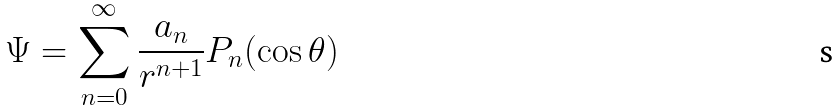Convert formula to latex. <formula><loc_0><loc_0><loc_500><loc_500>\Psi = \sum _ { n = 0 } ^ { \infty } \frac { a _ { n } } { r ^ { n + 1 } } P _ { n } ( \cos \theta )</formula> 